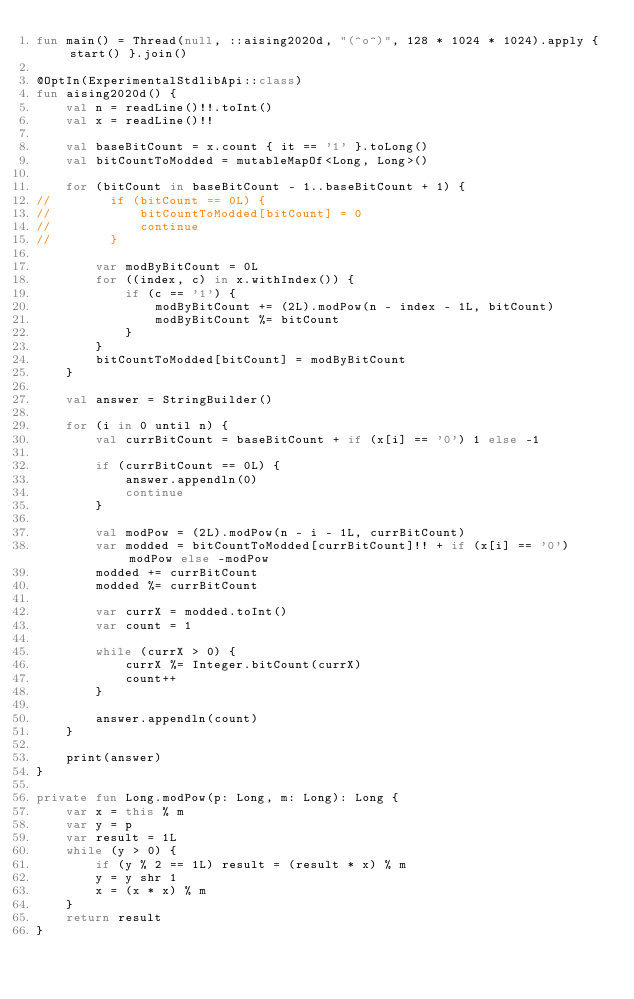Convert code to text. <code><loc_0><loc_0><loc_500><loc_500><_Kotlin_>fun main() = Thread(null, ::aising2020d, "(^o^)", 128 * 1024 * 1024).apply { start() }.join()

@OptIn(ExperimentalStdlibApi::class)
fun aising2020d() {
    val n = readLine()!!.toInt()
    val x = readLine()!!

    val baseBitCount = x.count { it == '1' }.toLong()
    val bitCountToModded = mutableMapOf<Long, Long>()

    for (bitCount in baseBitCount - 1..baseBitCount + 1) {
//        if (bitCount == 0L) {
//            bitCountToModded[bitCount] = 0
//            continue
//        }

        var modByBitCount = 0L
        for ((index, c) in x.withIndex()) {
            if (c == '1') {
                modByBitCount += (2L).modPow(n - index - 1L, bitCount)
                modByBitCount %= bitCount
            }
        }
        bitCountToModded[bitCount] = modByBitCount
    }

    val answer = StringBuilder()

    for (i in 0 until n) {
        val currBitCount = baseBitCount + if (x[i] == '0') 1 else -1

        if (currBitCount == 0L) {
            answer.appendln(0)
            continue
        }

        val modPow = (2L).modPow(n - i - 1L, currBitCount)
        var modded = bitCountToModded[currBitCount]!! + if (x[i] == '0') modPow else -modPow
        modded += currBitCount
        modded %= currBitCount

        var currX = modded.toInt()
        var count = 1

        while (currX > 0) {
            currX %= Integer.bitCount(currX)
            count++
        }

        answer.appendln(count)
    }

    print(answer)
}

private fun Long.modPow(p: Long, m: Long): Long {
    var x = this % m
    var y = p
    var result = 1L
    while (y > 0) {
        if (y % 2 == 1L) result = (result * x) % m
        y = y shr 1
        x = (x * x) % m
    }
    return result
}
</code> 